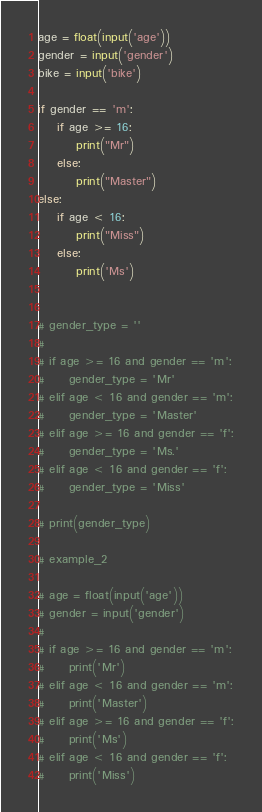<code> <loc_0><loc_0><loc_500><loc_500><_Python_>age = float(input('age'))
gender = input('gender')
bike = input('bike')

if gender == 'm':
    if age >= 16:
        print("Mr")
    else:
        print("Master")
else:
    if age < 16:
        print("Miss")
    else:
        print('Ms')


# gender_type = ''
#
# if age >= 16 and gender == 'm':
#     gender_type = 'Mr'
# elif age < 16 and gender == 'm':
#     gender_type = 'Master'
# elif age >= 16 and gender == 'f':
#     gender_type = 'Ms.'
# elif age < 16 and gender == 'f':
#     gender_type = 'Miss'

# print(gender_type)

# example_2

# age = float(input('age'))
# gender = input('gender')
#
# if age >= 16 and gender == 'm':
#     print('Mr')
# elif age < 16 and gender == 'm':
#     print('Master')
# elif age >= 16 and gender == 'f':
#     print('Ms')
# elif age < 16 and gender == 'f':
#     print('Miss')
</code> 